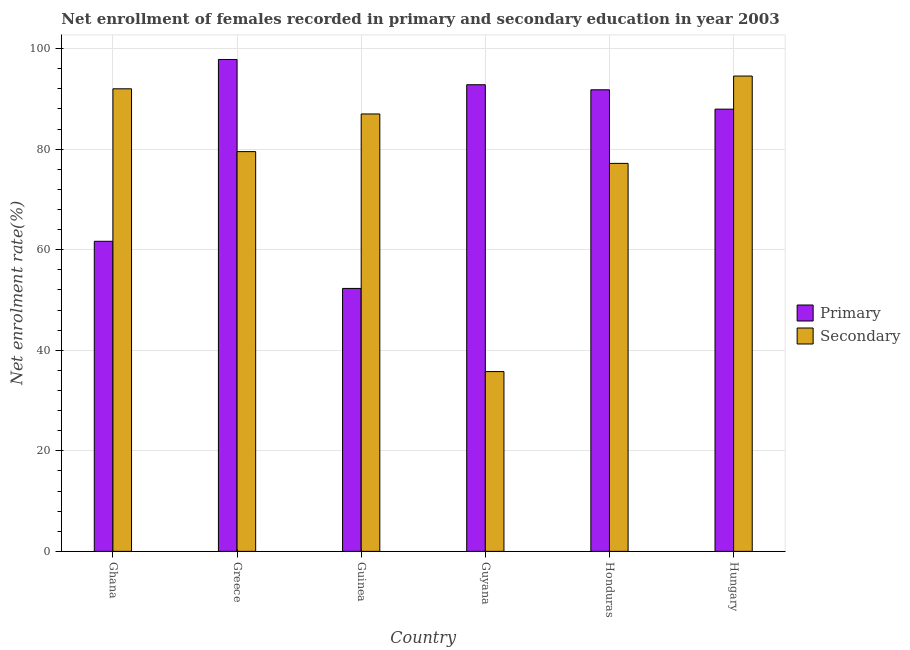How many different coloured bars are there?
Your response must be concise. 2. Are the number of bars on each tick of the X-axis equal?
Your answer should be compact. Yes. How many bars are there on the 3rd tick from the right?
Give a very brief answer. 2. What is the label of the 4th group of bars from the left?
Your answer should be very brief. Guyana. In how many cases, is the number of bars for a given country not equal to the number of legend labels?
Make the answer very short. 0. What is the enrollment rate in secondary education in Guinea?
Your answer should be compact. 87. Across all countries, what is the maximum enrollment rate in secondary education?
Provide a succinct answer. 94.54. Across all countries, what is the minimum enrollment rate in primary education?
Offer a very short reply. 52.3. In which country was the enrollment rate in primary education minimum?
Give a very brief answer. Guinea. What is the total enrollment rate in primary education in the graph?
Provide a succinct answer. 484.4. What is the difference between the enrollment rate in primary education in Guyana and that in Honduras?
Your answer should be compact. 1. What is the difference between the enrollment rate in primary education in Ghana and the enrollment rate in secondary education in Honduras?
Keep it short and to the point. -15.5. What is the average enrollment rate in primary education per country?
Ensure brevity in your answer.  80.73. What is the difference between the enrollment rate in primary education and enrollment rate in secondary education in Guyana?
Offer a very short reply. 57.05. What is the ratio of the enrollment rate in secondary education in Ghana to that in Guyana?
Your answer should be very brief. 2.57. What is the difference between the highest and the second highest enrollment rate in primary education?
Provide a short and direct response. 5.03. What is the difference between the highest and the lowest enrollment rate in primary education?
Provide a short and direct response. 45.54. Is the sum of the enrollment rate in primary education in Greece and Hungary greater than the maximum enrollment rate in secondary education across all countries?
Ensure brevity in your answer.  Yes. What does the 1st bar from the left in Hungary represents?
Provide a short and direct response. Primary. What does the 2nd bar from the right in Guyana represents?
Offer a very short reply. Primary. How many bars are there?
Your response must be concise. 12. What is the difference between two consecutive major ticks on the Y-axis?
Provide a succinct answer. 20. Does the graph contain any zero values?
Your answer should be very brief. No. How many legend labels are there?
Make the answer very short. 2. What is the title of the graph?
Your response must be concise. Net enrollment of females recorded in primary and secondary education in year 2003. What is the label or title of the Y-axis?
Offer a terse response. Net enrolment rate(%). What is the Net enrolment rate(%) of Primary in Ghana?
Make the answer very short. 61.68. What is the Net enrolment rate(%) in Secondary in Ghana?
Provide a short and direct response. 92.01. What is the Net enrolment rate(%) in Primary in Greece?
Keep it short and to the point. 97.84. What is the Net enrolment rate(%) in Secondary in Greece?
Your answer should be very brief. 79.51. What is the Net enrolment rate(%) in Primary in Guinea?
Offer a terse response. 52.3. What is the Net enrolment rate(%) in Secondary in Guinea?
Make the answer very short. 87. What is the Net enrolment rate(%) of Primary in Guyana?
Make the answer very short. 92.81. What is the Net enrolment rate(%) in Secondary in Guyana?
Make the answer very short. 35.76. What is the Net enrolment rate(%) in Primary in Honduras?
Provide a succinct answer. 91.81. What is the Net enrolment rate(%) of Secondary in Honduras?
Offer a very short reply. 77.17. What is the Net enrolment rate(%) of Primary in Hungary?
Your response must be concise. 87.96. What is the Net enrolment rate(%) in Secondary in Hungary?
Offer a very short reply. 94.54. Across all countries, what is the maximum Net enrolment rate(%) of Primary?
Keep it short and to the point. 97.84. Across all countries, what is the maximum Net enrolment rate(%) in Secondary?
Provide a short and direct response. 94.54. Across all countries, what is the minimum Net enrolment rate(%) in Primary?
Your answer should be very brief. 52.3. Across all countries, what is the minimum Net enrolment rate(%) in Secondary?
Offer a terse response. 35.76. What is the total Net enrolment rate(%) in Primary in the graph?
Your answer should be very brief. 484.4. What is the total Net enrolment rate(%) in Secondary in the graph?
Your answer should be compact. 466. What is the difference between the Net enrolment rate(%) in Primary in Ghana and that in Greece?
Make the answer very short. -36.17. What is the difference between the Net enrolment rate(%) in Secondary in Ghana and that in Greece?
Provide a short and direct response. 12.49. What is the difference between the Net enrolment rate(%) in Primary in Ghana and that in Guinea?
Give a very brief answer. 9.38. What is the difference between the Net enrolment rate(%) in Secondary in Ghana and that in Guinea?
Keep it short and to the point. 5. What is the difference between the Net enrolment rate(%) of Primary in Ghana and that in Guyana?
Your answer should be very brief. -31.14. What is the difference between the Net enrolment rate(%) in Secondary in Ghana and that in Guyana?
Give a very brief answer. 56.25. What is the difference between the Net enrolment rate(%) in Primary in Ghana and that in Honduras?
Offer a terse response. -30.14. What is the difference between the Net enrolment rate(%) of Secondary in Ghana and that in Honduras?
Make the answer very short. 14.84. What is the difference between the Net enrolment rate(%) of Primary in Ghana and that in Hungary?
Keep it short and to the point. -26.28. What is the difference between the Net enrolment rate(%) in Secondary in Ghana and that in Hungary?
Give a very brief answer. -2.54. What is the difference between the Net enrolment rate(%) in Primary in Greece and that in Guinea?
Your answer should be compact. 45.54. What is the difference between the Net enrolment rate(%) of Secondary in Greece and that in Guinea?
Offer a very short reply. -7.49. What is the difference between the Net enrolment rate(%) of Primary in Greece and that in Guyana?
Give a very brief answer. 5.03. What is the difference between the Net enrolment rate(%) of Secondary in Greece and that in Guyana?
Ensure brevity in your answer.  43.75. What is the difference between the Net enrolment rate(%) of Primary in Greece and that in Honduras?
Give a very brief answer. 6.03. What is the difference between the Net enrolment rate(%) of Secondary in Greece and that in Honduras?
Keep it short and to the point. 2.34. What is the difference between the Net enrolment rate(%) of Primary in Greece and that in Hungary?
Your answer should be compact. 9.88. What is the difference between the Net enrolment rate(%) in Secondary in Greece and that in Hungary?
Offer a very short reply. -15.03. What is the difference between the Net enrolment rate(%) in Primary in Guinea and that in Guyana?
Offer a terse response. -40.51. What is the difference between the Net enrolment rate(%) of Secondary in Guinea and that in Guyana?
Provide a short and direct response. 51.24. What is the difference between the Net enrolment rate(%) in Primary in Guinea and that in Honduras?
Make the answer very short. -39.51. What is the difference between the Net enrolment rate(%) in Secondary in Guinea and that in Honduras?
Keep it short and to the point. 9.83. What is the difference between the Net enrolment rate(%) of Primary in Guinea and that in Hungary?
Offer a terse response. -35.66. What is the difference between the Net enrolment rate(%) of Secondary in Guinea and that in Hungary?
Make the answer very short. -7.54. What is the difference between the Net enrolment rate(%) of Primary in Guyana and that in Honduras?
Make the answer very short. 1. What is the difference between the Net enrolment rate(%) of Secondary in Guyana and that in Honduras?
Provide a succinct answer. -41.41. What is the difference between the Net enrolment rate(%) of Primary in Guyana and that in Hungary?
Provide a short and direct response. 4.85. What is the difference between the Net enrolment rate(%) of Secondary in Guyana and that in Hungary?
Give a very brief answer. -58.79. What is the difference between the Net enrolment rate(%) of Primary in Honduras and that in Hungary?
Your response must be concise. 3.85. What is the difference between the Net enrolment rate(%) of Secondary in Honduras and that in Hungary?
Give a very brief answer. -17.37. What is the difference between the Net enrolment rate(%) of Primary in Ghana and the Net enrolment rate(%) of Secondary in Greece?
Your response must be concise. -17.84. What is the difference between the Net enrolment rate(%) in Primary in Ghana and the Net enrolment rate(%) in Secondary in Guinea?
Give a very brief answer. -25.33. What is the difference between the Net enrolment rate(%) of Primary in Ghana and the Net enrolment rate(%) of Secondary in Guyana?
Provide a short and direct response. 25.92. What is the difference between the Net enrolment rate(%) in Primary in Ghana and the Net enrolment rate(%) in Secondary in Honduras?
Keep it short and to the point. -15.5. What is the difference between the Net enrolment rate(%) in Primary in Ghana and the Net enrolment rate(%) in Secondary in Hungary?
Provide a short and direct response. -32.87. What is the difference between the Net enrolment rate(%) of Primary in Greece and the Net enrolment rate(%) of Secondary in Guinea?
Give a very brief answer. 10.84. What is the difference between the Net enrolment rate(%) in Primary in Greece and the Net enrolment rate(%) in Secondary in Guyana?
Make the answer very short. 62.08. What is the difference between the Net enrolment rate(%) in Primary in Greece and the Net enrolment rate(%) in Secondary in Honduras?
Offer a very short reply. 20.67. What is the difference between the Net enrolment rate(%) in Primary in Greece and the Net enrolment rate(%) in Secondary in Hungary?
Make the answer very short. 3.3. What is the difference between the Net enrolment rate(%) of Primary in Guinea and the Net enrolment rate(%) of Secondary in Guyana?
Your response must be concise. 16.54. What is the difference between the Net enrolment rate(%) of Primary in Guinea and the Net enrolment rate(%) of Secondary in Honduras?
Your answer should be compact. -24.87. What is the difference between the Net enrolment rate(%) in Primary in Guinea and the Net enrolment rate(%) in Secondary in Hungary?
Offer a terse response. -42.25. What is the difference between the Net enrolment rate(%) in Primary in Guyana and the Net enrolment rate(%) in Secondary in Honduras?
Offer a very short reply. 15.64. What is the difference between the Net enrolment rate(%) of Primary in Guyana and the Net enrolment rate(%) of Secondary in Hungary?
Keep it short and to the point. -1.73. What is the difference between the Net enrolment rate(%) of Primary in Honduras and the Net enrolment rate(%) of Secondary in Hungary?
Ensure brevity in your answer.  -2.73. What is the average Net enrolment rate(%) of Primary per country?
Offer a terse response. 80.73. What is the average Net enrolment rate(%) in Secondary per country?
Your answer should be compact. 77.67. What is the difference between the Net enrolment rate(%) of Primary and Net enrolment rate(%) of Secondary in Ghana?
Your answer should be compact. -30.33. What is the difference between the Net enrolment rate(%) of Primary and Net enrolment rate(%) of Secondary in Greece?
Ensure brevity in your answer.  18.33. What is the difference between the Net enrolment rate(%) in Primary and Net enrolment rate(%) in Secondary in Guinea?
Offer a terse response. -34.7. What is the difference between the Net enrolment rate(%) of Primary and Net enrolment rate(%) of Secondary in Guyana?
Keep it short and to the point. 57.05. What is the difference between the Net enrolment rate(%) in Primary and Net enrolment rate(%) in Secondary in Honduras?
Your answer should be compact. 14.64. What is the difference between the Net enrolment rate(%) in Primary and Net enrolment rate(%) in Secondary in Hungary?
Make the answer very short. -6.59. What is the ratio of the Net enrolment rate(%) in Primary in Ghana to that in Greece?
Provide a succinct answer. 0.63. What is the ratio of the Net enrolment rate(%) in Secondary in Ghana to that in Greece?
Your answer should be compact. 1.16. What is the ratio of the Net enrolment rate(%) of Primary in Ghana to that in Guinea?
Keep it short and to the point. 1.18. What is the ratio of the Net enrolment rate(%) in Secondary in Ghana to that in Guinea?
Your answer should be compact. 1.06. What is the ratio of the Net enrolment rate(%) in Primary in Ghana to that in Guyana?
Provide a succinct answer. 0.66. What is the ratio of the Net enrolment rate(%) in Secondary in Ghana to that in Guyana?
Keep it short and to the point. 2.57. What is the ratio of the Net enrolment rate(%) of Primary in Ghana to that in Honduras?
Give a very brief answer. 0.67. What is the ratio of the Net enrolment rate(%) in Secondary in Ghana to that in Honduras?
Make the answer very short. 1.19. What is the ratio of the Net enrolment rate(%) in Primary in Ghana to that in Hungary?
Make the answer very short. 0.7. What is the ratio of the Net enrolment rate(%) of Secondary in Ghana to that in Hungary?
Keep it short and to the point. 0.97. What is the ratio of the Net enrolment rate(%) of Primary in Greece to that in Guinea?
Give a very brief answer. 1.87. What is the ratio of the Net enrolment rate(%) of Secondary in Greece to that in Guinea?
Keep it short and to the point. 0.91. What is the ratio of the Net enrolment rate(%) in Primary in Greece to that in Guyana?
Your answer should be compact. 1.05. What is the ratio of the Net enrolment rate(%) in Secondary in Greece to that in Guyana?
Ensure brevity in your answer.  2.22. What is the ratio of the Net enrolment rate(%) in Primary in Greece to that in Honduras?
Provide a succinct answer. 1.07. What is the ratio of the Net enrolment rate(%) of Secondary in Greece to that in Honduras?
Your response must be concise. 1.03. What is the ratio of the Net enrolment rate(%) of Primary in Greece to that in Hungary?
Offer a terse response. 1.11. What is the ratio of the Net enrolment rate(%) in Secondary in Greece to that in Hungary?
Ensure brevity in your answer.  0.84. What is the ratio of the Net enrolment rate(%) of Primary in Guinea to that in Guyana?
Offer a very short reply. 0.56. What is the ratio of the Net enrolment rate(%) in Secondary in Guinea to that in Guyana?
Keep it short and to the point. 2.43. What is the ratio of the Net enrolment rate(%) in Primary in Guinea to that in Honduras?
Provide a succinct answer. 0.57. What is the ratio of the Net enrolment rate(%) in Secondary in Guinea to that in Honduras?
Ensure brevity in your answer.  1.13. What is the ratio of the Net enrolment rate(%) of Primary in Guinea to that in Hungary?
Your answer should be compact. 0.59. What is the ratio of the Net enrolment rate(%) in Secondary in Guinea to that in Hungary?
Keep it short and to the point. 0.92. What is the ratio of the Net enrolment rate(%) of Primary in Guyana to that in Honduras?
Your response must be concise. 1.01. What is the ratio of the Net enrolment rate(%) in Secondary in Guyana to that in Honduras?
Keep it short and to the point. 0.46. What is the ratio of the Net enrolment rate(%) of Primary in Guyana to that in Hungary?
Your answer should be very brief. 1.06. What is the ratio of the Net enrolment rate(%) of Secondary in Guyana to that in Hungary?
Ensure brevity in your answer.  0.38. What is the ratio of the Net enrolment rate(%) of Primary in Honduras to that in Hungary?
Provide a succinct answer. 1.04. What is the ratio of the Net enrolment rate(%) in Secondary in Honduras to that in Hungary?
Your answer should be compact. 0.82. What is the difference between the highest and the second highest Net enrolment rate(%) in Primary?
Offer a very short reply. 5.03. What is the difference between the highest and the second highest Net enrolment rate(%) in Secondary?
Offer a terse response. 2.54. What is the difference between the highest and the lowest Net enrolment rate(%) in Primary?
Provide a short and direct response. 45.54. What is the difference between the highest and the lowest Net enrolment rate(%) of Secondary?
Your answer should be very brief. 58.79. 